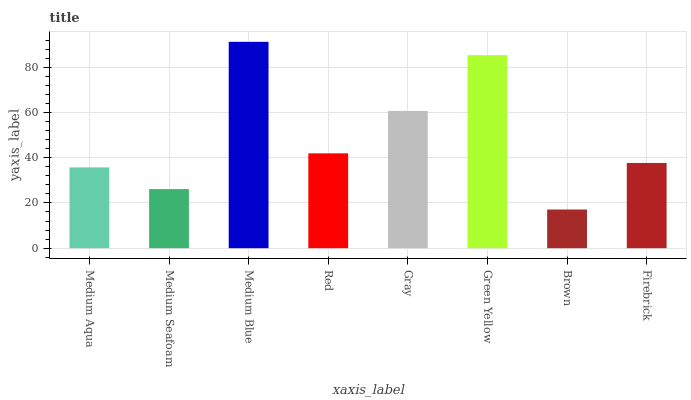Is Brown the minimum?
Answer yes or no. Yes. Is Medium Blue the maximum?
Answer yes or no. Yes. Is Medium Seafoam the minimum?
Answer yes or no. No. Is Medium Seafoam the maximum?
Answer yes or no. No. Is Medium Aqua greater than Medium Seafoam?
Answer yes or no. Yes. Is Medium Seafoam less than Medium Aqua?
Answer yes or no. Yes. Is Medium Seafoam greater than Medium Aqua?
Answer yes or no. No. Is Medium Aqua less than Medium Seafoam?
Answer yes or no. No. Is Red the high median?
Answer yes or no. Yes. Is Firebrick the low median?
Answer yes or no. Yes. Is Medium Blue the high median?
Answer yes or no. No. Is Medium Blue the low median?
Answer yes or no. No. 